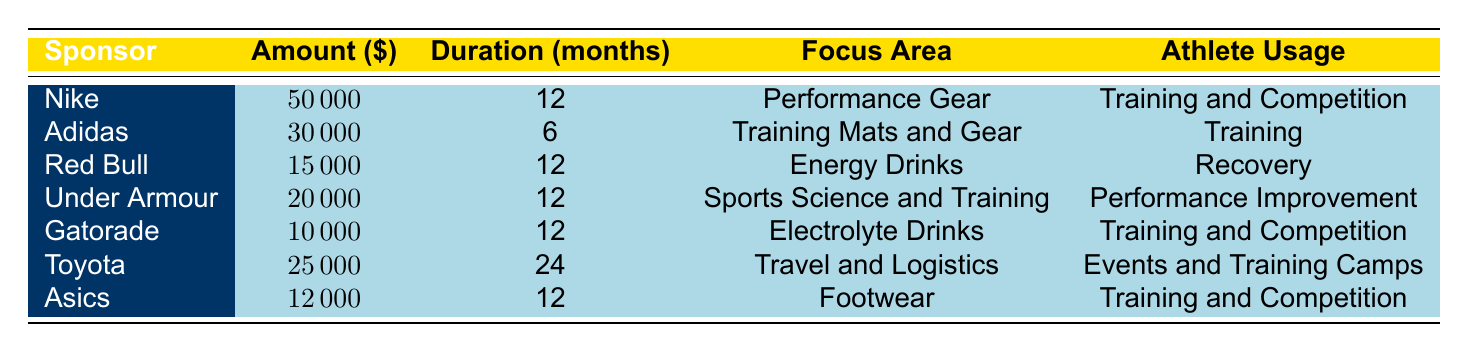What is the total funding provided by all sponsors? To find the total funding, add the amounts from all sponsors: 50000 (Nike) + 30000 (Adidas) + 15000 (Red Bull) + 20000 (Under Armour) + 10000 (Gatorade) + 25000 (Toyota) + 12000 (Asics) = 162000.
Answer: 162000 Which sponsor provides the longest duration of sponsorship? Looking at the durations listed in the table, Toyota offers the longest duration of sponsorship at 24 months.
Answer: Toyota How much funding does Gatorade provide compared to Red Bull? Gatorade provides 10000 while Red Bull provides 15000. The difference between them is 15000 (Red Bull) - 10000 (Gatorade) = 5000.
Answer: 5000 Is Under Armour the only sponsor providing financial support? Reviewing the table, Under Armour is categorized as financial support, while others are categorized separately. Therefore, Under Armour is not the only sponsor; other categories exist like equipment and apparel sponsorships.
Answer: No What percentage of the total funding does Nike contribute? Nike’s funding is 50000, and total funding is 162000. To find the percentage, divide Nike's funding by total funding (50000/162000) and multiply by 100. This results in approximately 30.86%.
Answer: 30.86% How many sponsors focus on training-related products or services? The relevant sponsors focusing on training are: Adidas (Training Mats and Gear), Gatorade (Training and Competition), Asics (Training and Competition), and Under Armour (Performance Improvement). There are 4 sponsors.
Answer: 4 What is the average funding amount provided by sponsors that focus on hydration? Only one sponsor focuses on hydration: Gatorade with an amount of 10000. So, the average is 10000 since there is only one data point.
Answer: 10000 Which sponsors provide support for both competitions and training? Looking through the table, Nike, Gatorade, and Asics provide support for both training and competition.
Answer: Nike, Gatorade, Asics How many sponsors have a funding amount greater than 20000? Referring to the table, Nike (50000) and Toyota (25000) are the sponsors with amounts greater than 20000. Therefore, there are 2 sponsors.
Answer: 2 